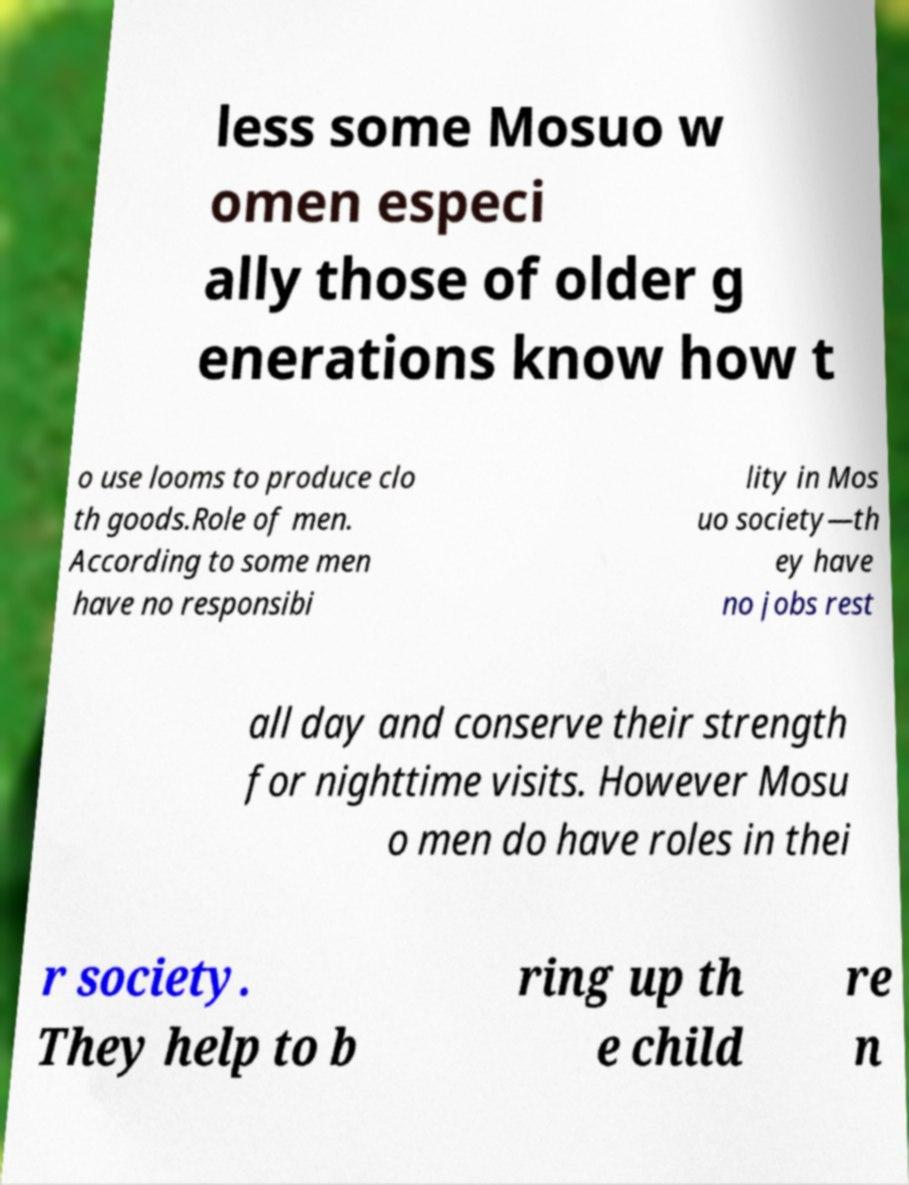Can you accurately transcribe the text from the provided image for me? less some Mosuo w omen especi ally those of older g enerations know how t o use looms to produce clo th goods.Role of men. According to some men have no responsibi lity in Mos uo society—th ey have no jobs rest all day and conserve their strength for nighttime visits. However Mosu o men do have roles in thei r society. They help to b ring up th e child re n 